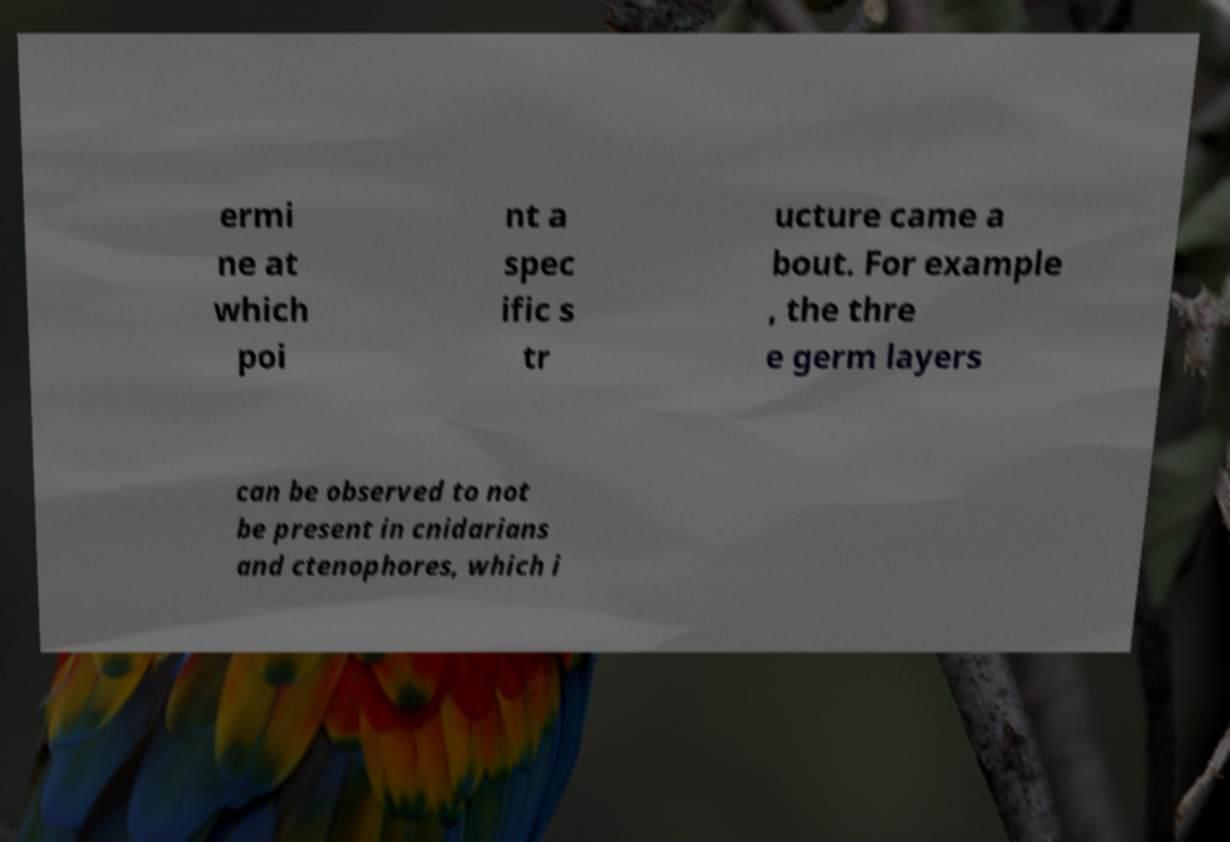Can you read and provide the text displayed in the image?This photo seems to have some interesting text. Can you extract and type it out for me? ermi ne at which poi nt a spec ific s tr ucture came a bout. For example , the thre e germ layers can be observed to not be present in cnidarians and ctenophores, which i 